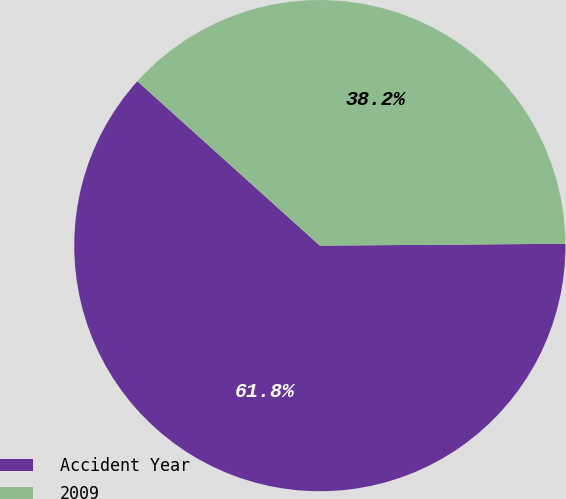Convert chart. <chart><loc_0><loc_0><loc_500><loc_500><pie_chart><fcel>Accident Year<fcel>2009<nl><fcel>61.79%<fcel>38.21%<nl></chart> 